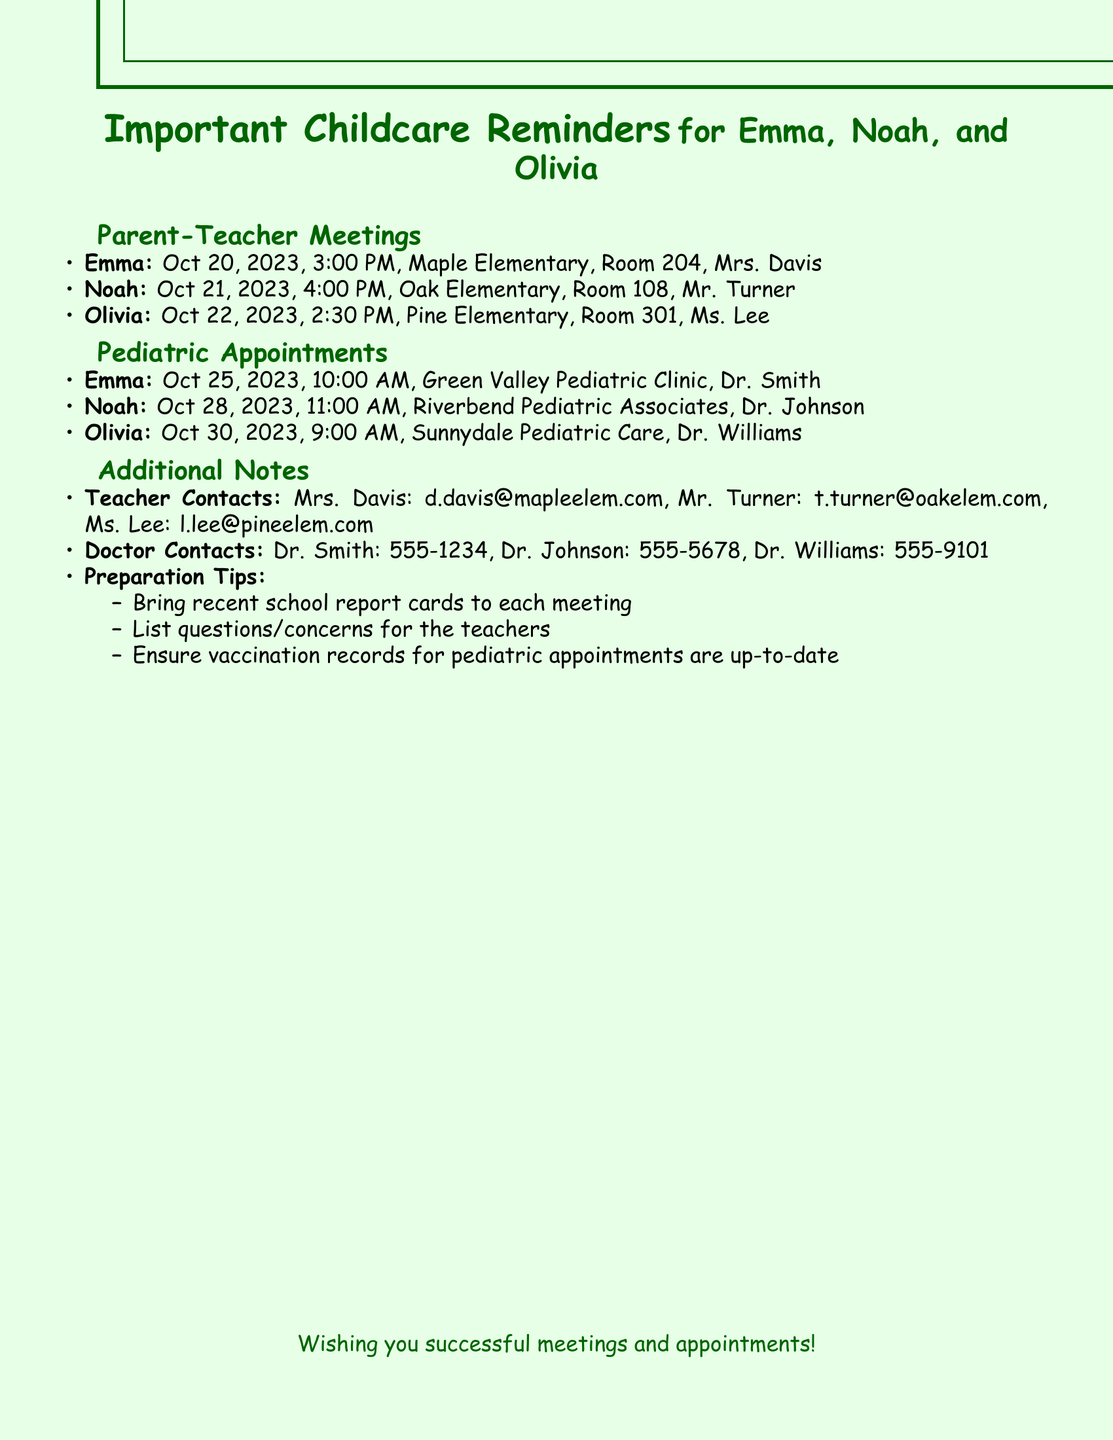What date is Emma's parent-teacher meeting? The document lists specific dates for each child's parent-teacher meeting, with Emma's meeting on October 20, 2023.
Answer: October 20, 2023 What time is Noah's pediatric appointment? The document provides the times for each pediatric appointment, and Noah's appointment is at 11:00 AM.
Answer: 11:00 AM Who is Olivia's teacher? The document specifies the teachers for each child, and Olivia's teacher is Ms. Lee.
Answer: Ms. Lee What is the contact number for Dr. Johnson? The document includes contact numbers for each doctor, and Dr. Johnson's number is listed as 555-5678.
Answer: 555-5678 What should be brought to each meeting? The document provides preparation tips, including bringing recent school report cards to each meeting.
Answer: Recent school report cards How many pediatric appointments are listed? By counting the appointments in the document for the three children, we find there are three pediatric appointments listed.
Answer: Three What is the location of Olivia's pediatric appointment? The document includes locations for each child's appointment, and Olivia's appointment is at Sunnydale Pediatric Care.
Answer: Sunnydale Pediatric Care What email address is provided for Mrs. Davis? The document specifies teacher contacts, and Mrs. Davis's email address is d.davis@mapleelem.com.
Answer: d.davis@mapleelem.com 